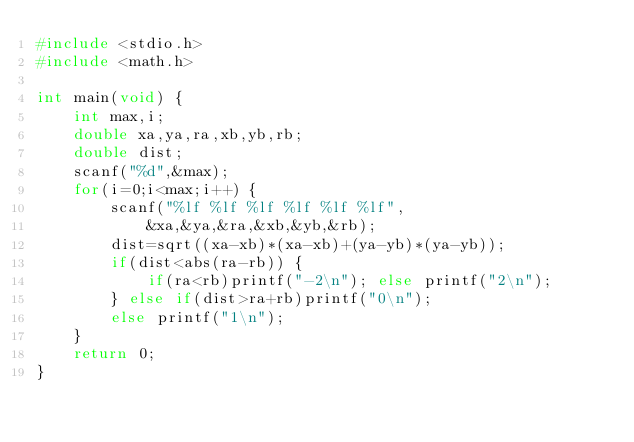<code> <loc_0><loc_0><loc_500><loc_500><_C_>#include <stdio.h>
#include <math.h>

int main(void) {
	int max,i;
	double xa,ya,ra,xb,yb,rb;
	double dist;
	scanf("%d",&max);
	for(i=0;i<max;i++) {
		scanf("%lf %lf %lf %lf %lf %lf",
			&xa,&ya,&ra,&xb,&yb,&rb);
		dist=sqrt((xa-xb)*(xa-xb)+(ya-yb)*(ya-yb));
		if(dist<abs(ra-rb)) {
			if(ra<rb)printf("-2\n"); else printf("2\n");
		} else if(dist>ra+rb)printf("0\n");
		else printf("1\n");
	}
	return 0;
}</code> 